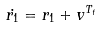Convert formula to latex. <formula><loc_0><loc_0><loc_500><loc_500>\dot { r _ { 1 } } = r _ { 1 } + v ^ { T _ { t } }</formula> 